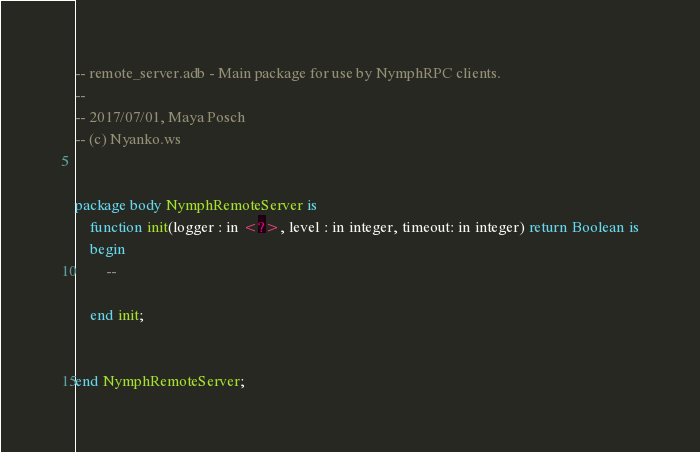Convert code to text. <code><loc_0><loc_0><loc_500><loc_500><_Ada_>-- remote_server.adb - Main package for use by NymphRPC clients.
--
-- 2017/07/01, Maya Posch
-- (c) Nyanko.ws


package body NymphRemoteServer is
	function init(logger : in <?>, level : in integer, timeout: in integer) return Boolean is
	begin
		--
		
	end init;
	
	
end NymphRemoteServer;
</code> 